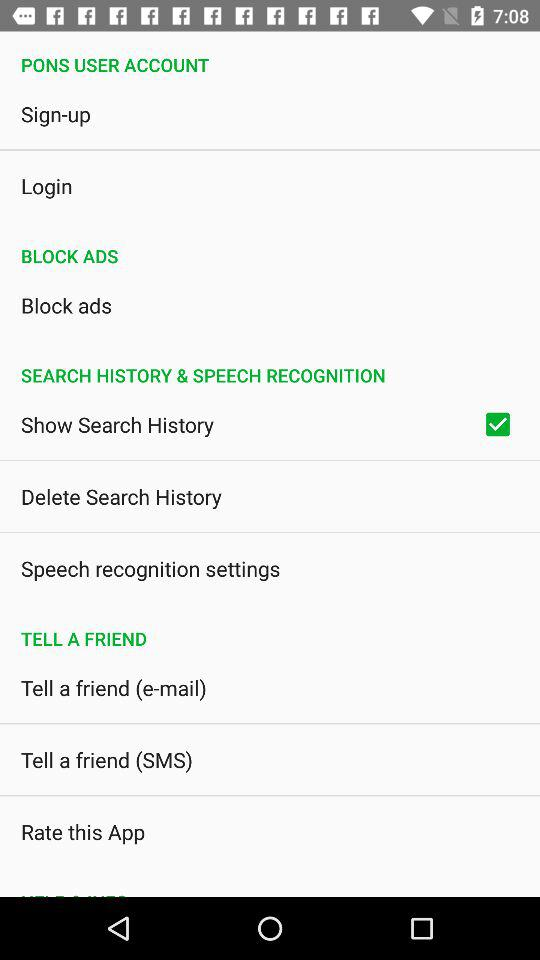What is the status of "Show Search History"? The status is "on". 